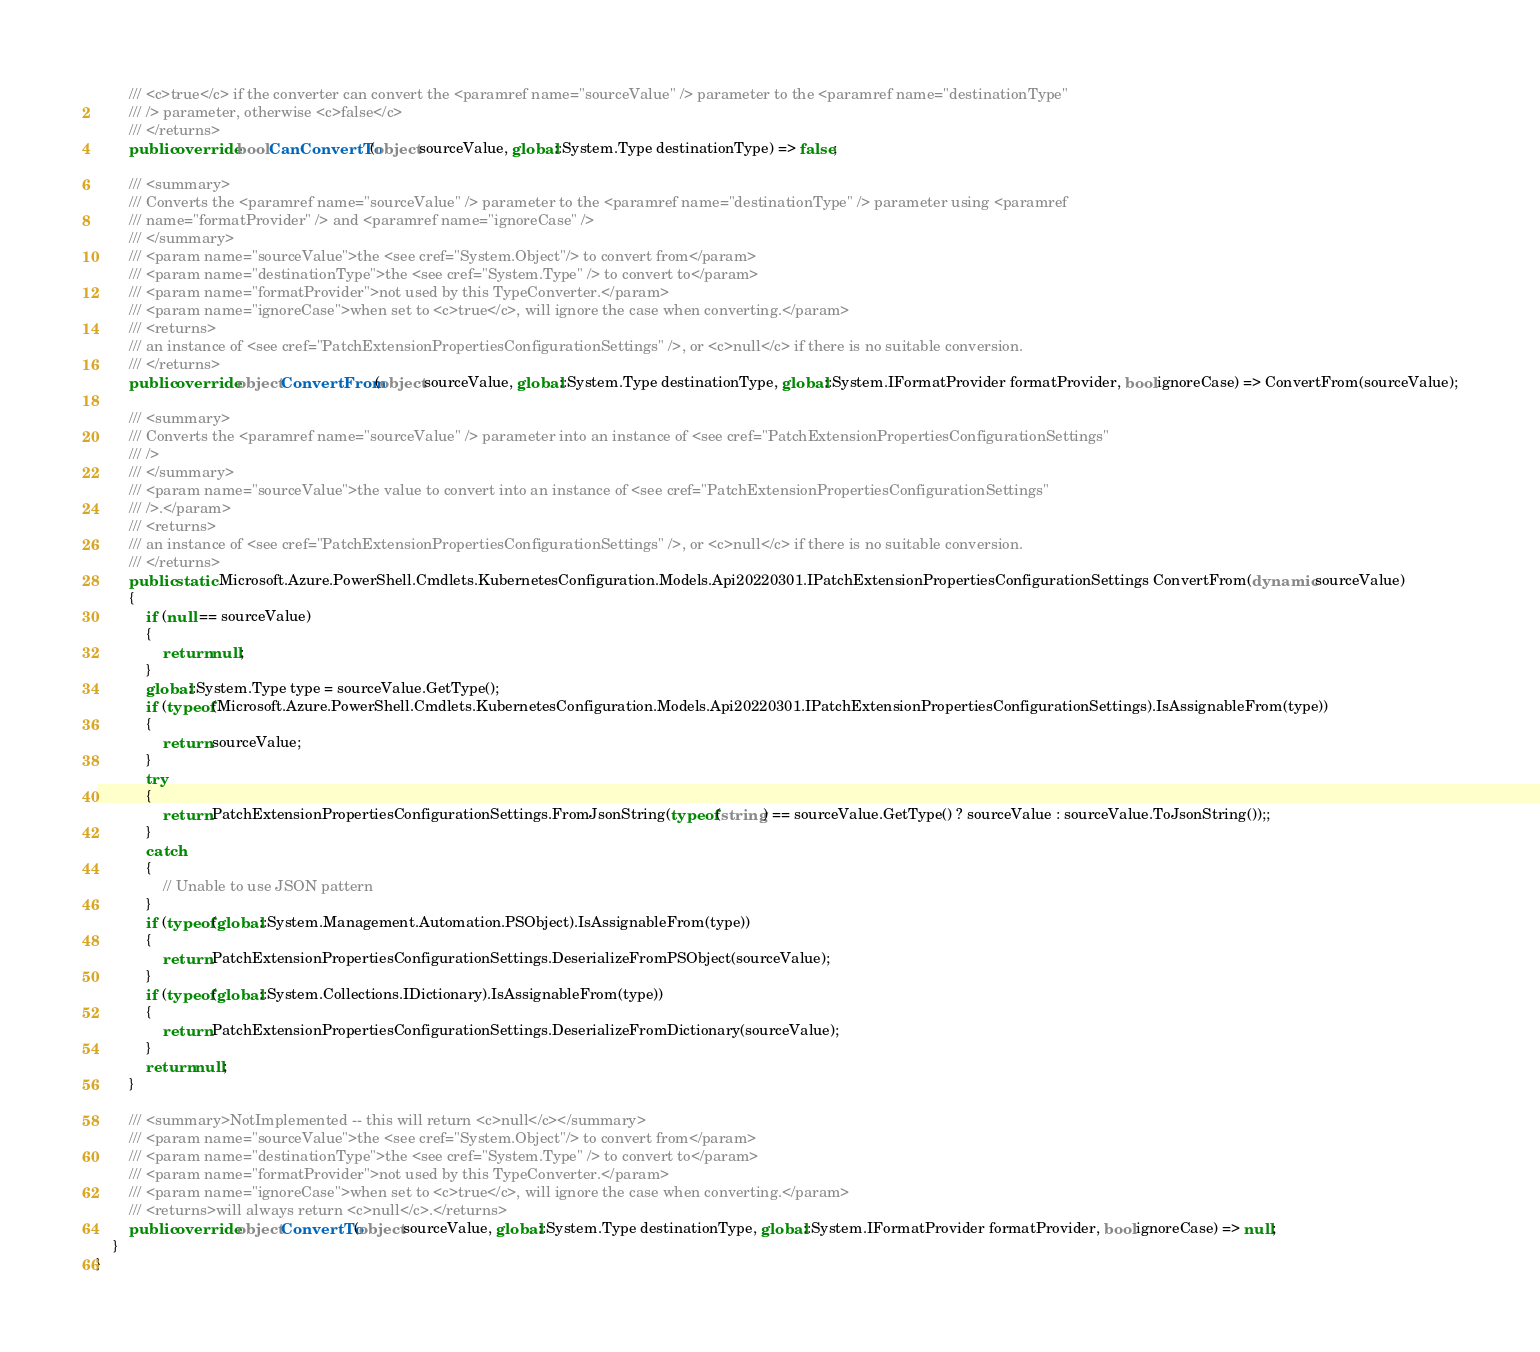<code> <loc_0><loc_0><loc_500><loc_500><_C#_>        /// <c>true</c> if the converter can convert the <paramref name="sourceValue" /> parameter to the <paramref name="destinationType"
        /// /> parameter, otherwise <c>false</c>
        /// </returns>
        public override bool CanConvertTo(object sourceValue, global::System.Type destinationType) => false;

        /// <summary>
        /// Converts the <paramref name="sourceValue" /> parameter to the <paramref name="destinationType" /> parameter using <paramref
        /// name="formatProvider" /> and <paramref name="ignoreCase" />
        /// </summary>
        /// <param name="sourceValue">the <see cref="System.Object"/> to convert from</param>
        /// <param name="destinationType">the <see cref="System.Type" /> to convert to</param>
        /// <param name="formatProvider">not used by this TypeConverter.</param>
        /// <param name="ignoreCase">when set to <c>true</c>, will ignore the case when converting.</param>
        /// <returns>
        /// an instance of <see cref="PatchExtensionPropertiesConfigurationSettings" />, or <c>null</c> if there is no suitable conversion.
        /// </returns>
        public override object ConvertFrom(object sourceValue, global::System.Type destinationType, global::System.IFormatProvider formatProvider, bool ignoreCase) => ConvertFrom(sourceValue);

        /// <summary>
        /// Converts the <paramref name="sourceValue" /> parameter into an instance of <see cref="PatchExtensionPropertiesConfigurationSettings"
        /// />
        /// </summary>
        /// <param name="sourceValue">the value to convert into an instance of <see cref="PatchExtensionPropertiesConfigurationSettings"
        /// />.</param>
        /// <returns>
        /// an instance of <see cref="PatchExtensionPropertiesConfigurationSettings" />, or <c>null</c> if there is no suitable conversion.
        /// </returns>
        public static Microsoft.Azure.PowerShell.Cmdlets.KubernetesConfiguration.Models.Api20220301.IPatchExtensionPropertiesConfigurationSettings ConvertFrom(dynamic sourceValue)
        {
            if (null == sourceValue)
            {
                return null;
            }
            global::System.Type type = sourceValue.GetType();
            if (typeof(Microsoft.Azure.PowerShell.Cmdlets.KubernetesConfiguration.Models.Api20220301.IPatchExtensionPropertiesConfigurationSettings).IsAssignableFrom(type))
            {
                return sourceValue;
            }
            try
            {
                return PatchExtensionPropertiesConfigurationSettings.FromJsonString(typeof(string) == sourceValue.GetType() ? sourceValue : sourceValue.ToJsonString());;
            }
            catch
            {
                // Unable to use JSON pattern
            }
            if (typeof(global::System.Management.Automation.PSObject).IsAssignableFrom(type))
            {
                return PatchExtensionPropertiesConfigurationSettings.DeserializeFromPSObject(sourceValue);
            }
            if (typeof(global::System.Collections.IDictionary).IsAssignableFrom(type))
            {
                return PatchExtensionPropertiesConfigurationSettings.DeserializeFromDictionary(sourceValue);
            }
            return null;
        }

        /// <summary>NotImplemented -- this will return <c>null</c></summary>
        /// <param name="sourceValue">the <see cref="System.Object"/> to convert from</param>
        /// <param name="destinationType">the <see cref="System.Type" /> to convert to</param>
        /// <param name="formatProvider">not used by this TypeConverter.</param>
        /// <param name="ignoreCase">when set to <c>true</c>, will ignore the case when converting.</param>
        /// <returns>will always return <c>null</c>.</returns>
        public override object ConvertTo(object sourceValue, global::System.Type destinationType, global::System.IFormatProvider formatProvider, bool ignoreCase) => null;
    }
}</code> 